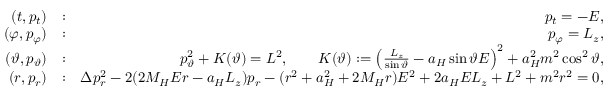Convert formula to latex. <formula><loc_0><loc_0><loc_500><loc_500>\begin{array} { r l r } { ( t , p _ { t } ) } & { \colon } & { p _ { t } = - E , } \\ { ( \varphi , p _ { \varphi } ) } & { \colon } & { p _ { \varphi } = L _ { z } , } \\ { ( \vartheta , p _ { \vartheta } ) } & { \colon } & { p _ { \vartheta } ^ { 2 } + K ( \vartheta ) = L ^ { 2 } , \quad K ( \vartheta ) \colon = \left ( \frac { L _ { z } } { \sin \vartheta } - a _ { H } \sin \vartheta E \right ) ^ { 2 } + a _ { H } ^ { 2 } m ^ { 2 } \cos ^ { 2 } \vartheta , } \\ { ( r , p _ { r } ) } & { \colon } & { \Delta p _ { r } ^ { 2 } - 2 ( 2 M _ { H } E r - a _ { H } L _ { z } ) p _ { r } - ( r ^ { 2 } + a _ { H } ^ { 2 } + 2 M _ { H } r ) E ^ { 2 } + 2 a _ { H } E L _ { z } + L ^ { 2 } + m ^ { 2 } r ^ { 2 } = 0 , } \end{array}</formula> 